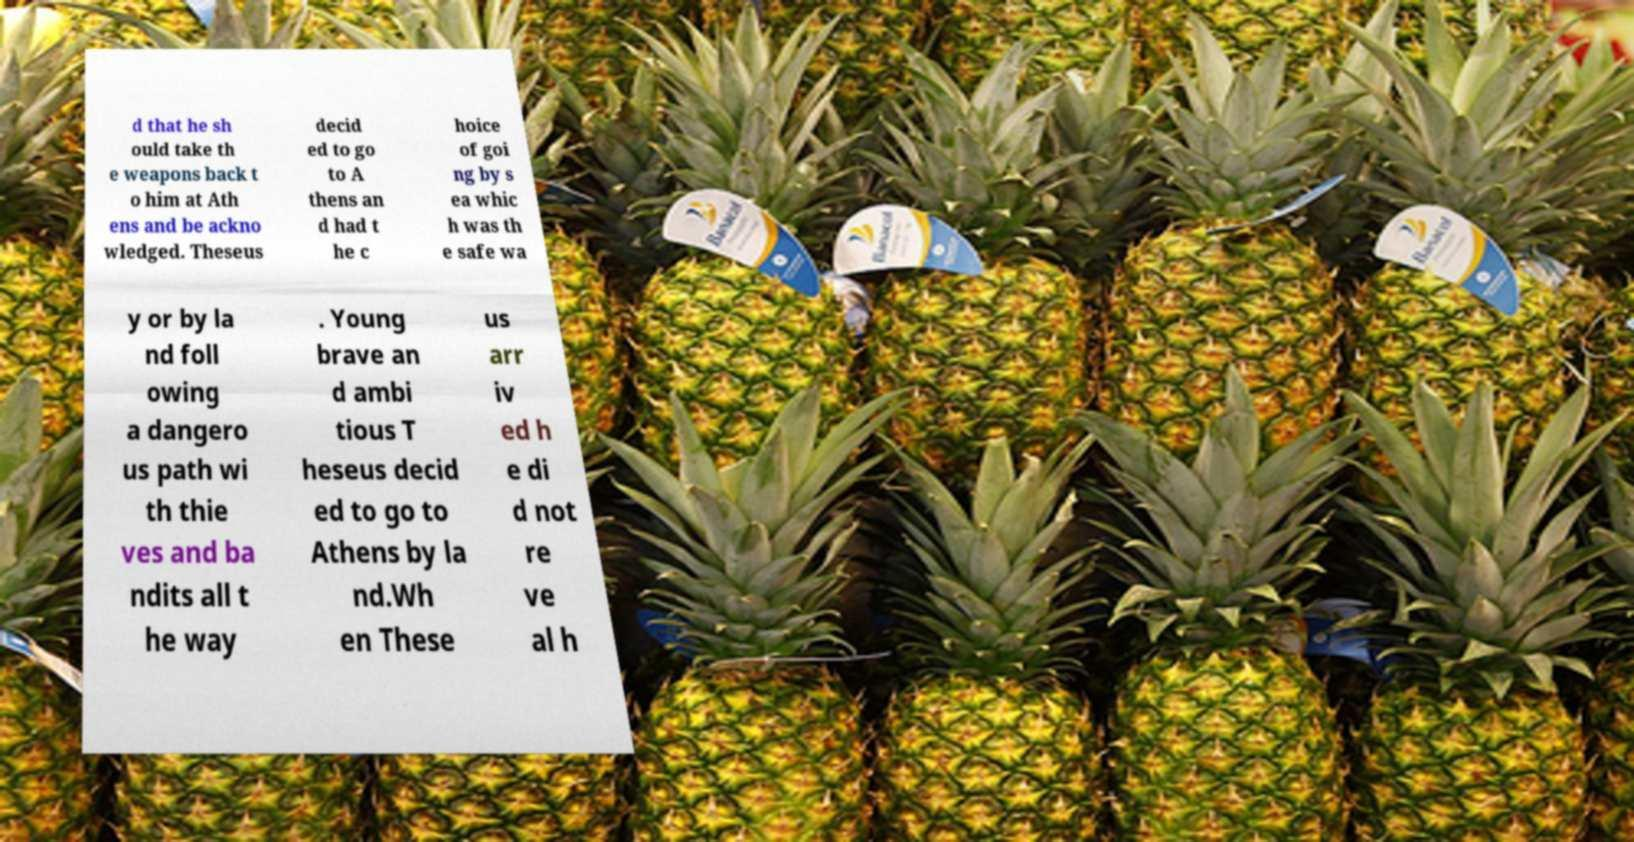For documentation purposes, I need the text within this image transcribed. Could you provide that? d that he sh ould take th e weapons back t o him at Ath ens and be ackno wledged. Theseus decid ed to go to A thens an d had t he c hoice of goi ng by s ea whic h was th e safe wa y or by la nd foll owing a dangero us path wi th thie ves and ba ndits all t he way . Young brave an d ambi tious T heseus decid ed to go to Athens by la nd.Wh en These us arr iv ed h e di d not re ve al h 